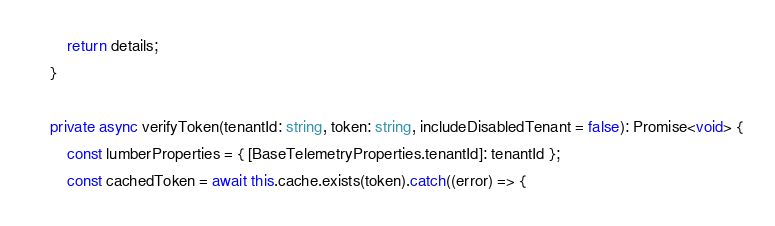<code> <loc_0><loc_0><loc_500><loc_500><_TypeScript_>        return details;
    }

    private async verifyToken(tenantId: string, token: string, includeDisabledTenant = false): Promise<void> {
        const lumberProperties = { [BaseTelemetryProperties.tenantId]: tenantId };
        const cachedToken = await this.cache.exists(token).catch((error) => {</code> 